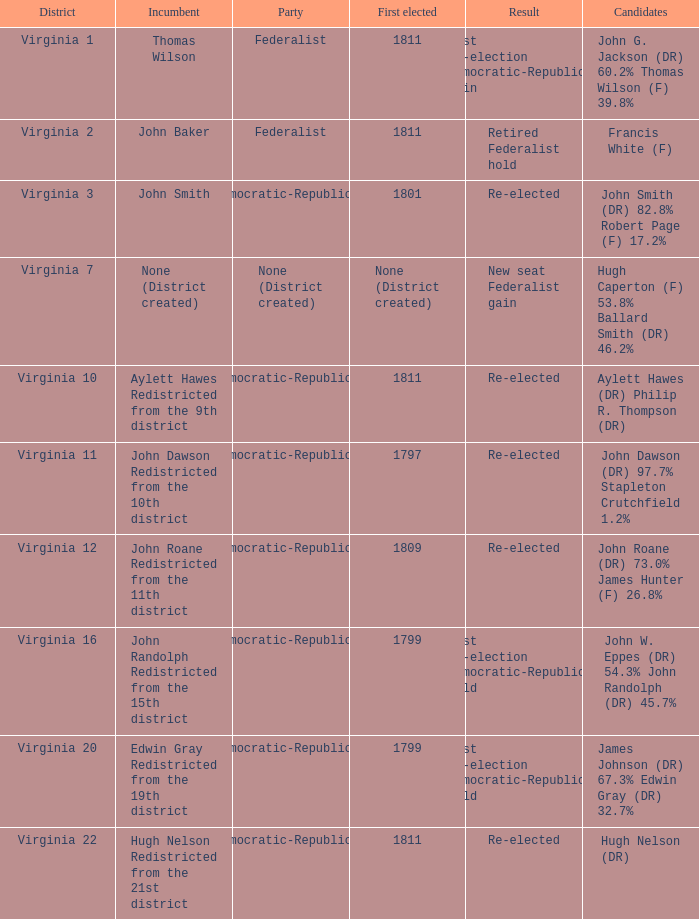Specify the political party in virginia district 12 Democratic-Republican. Would you mind parsing the complete table? {'header': ['District', 'Incumbent', 'Party', 'First elected', 'Result', 'Candidates'], 'rows': [['Virginia 1', 'Thomas Wilson', 'Federalist', '1811', 'Lost re-election Democratic-Republican gain', 'John G. Jackson (DR) 60.2% Thomas Wilson (F) 39.8%'], ['Virginia 2', 'John Baker', 'Federalist', '1811', 'Retired Federalist hold', 'Francis White (F)'], ['Virginia 3', 'John Smith', 'Democratic-Republican', '1801', 'Re-elected', 'John Smith (DR) 82.8% Robert Page (F) 17.2%'], ['Virginia 7', 'None (District created)', 'None (District created)', 'None (District created)', 'New seat Federalist gain', 'Hugh Caperton (F) 53.8% Ballard Smith (DR) 46.2%'], ['Virginia 10', 'Aylett Hawes Redistricted from the 9th district', 'Democratic-Republican', '1811', 'Re-elected', 'Aylett Hawes (DR) Philip R. Thompson (DR)'], ['Virginia 11', 'John Dawson Redistricted from the 10th district', 'Democratic-Republican', '1797', 'Re-elected', 'John Dawson (DR) 97.7% Stapleton Crutchfield 1.2%'], ['Virginia 12', 'John Roane Redistricted from the 11th district', 'Democratic-Republican', '1809', 'Re-elected', 'John Roane (DR) 73.0% James Hunter (F) 26.8%'], ['Virginia 16', 'John Randolph Redistricted from the 15th district', 'Democratic-Republican', '1799', 'Lost re-election Democratic-Republican hold', 'John W. Eppes (DR) 54.3% John Randolph (DR) 45.7%'], ['Virginia 20', 'Edwin Gray Redistricted from the 19th district', 'Democratic-Republican', '1799', 'Lost re-election Democratic-Republican hold', 'James Johnson (DR) 67.3% Edwin Gray (DR) 32.7%'], ['Virginia 22', 'Hugh Nelson Redistricted from the 21st district', 'Democratic-Republican', '1811', 'Re-elected', 'Hugh Nelson (DR)']]} 